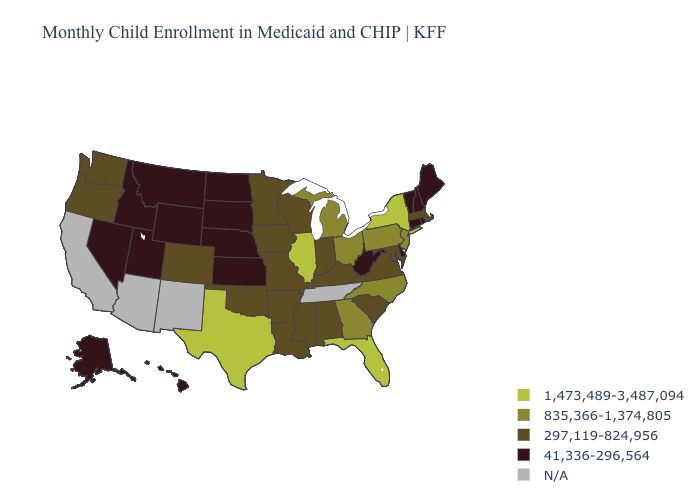Among the states that border New York , which have the highest value?
Give a very brief answer. New Jersey, Pennsylvania. What is the value of Missouri?
Give a very brief answer. 297,119-824,956. Name the states that have a value in the range N/A?
Quick response, please. Arizona, California, New Mexico, Tennessee. Does Connecticut have the highest value in the Northeast?
Keep it brief. No. Name the states that have a value in the range 297,119-824,956?
Quick response, please. Alabama, Arkansas, Colorado, Indiana, Iowa, Kentucky, Louisiana, Maryland, Massachusetts, Minnesota, Mississippi, Missouri, Oklahoma, Oregon, South Carolina, Virginia, Washington, Wisconsin. Does the map have missing data?
Quick response, please. Yes. What is the value of Kentucky?
Quick response, please. 297,119-824,956. Which states have the lowest value in the Northeast?
Quick response, please. Connecticut, Maine, New Hampshire, Rhode Island, Vermont. Among the states that border New Mexico , which have the lowest value?
Be succinct. Utah. Name the states that have a value in the range N/A?
Short answer required. Arizona, California, New Mexico, Tennessee. Does Utah have the highest value in the USA?
Concise answer only. No. What is the value of South Dakota?
Give a very brief answer. 41,336-296,564. Does the map have missing data?
Answer briefly. Yes. What is the value of Texas?
Keep it brief. 1,473,489-3,487,094. What is the highest value in the USA?
Write a very short answer. 1,473,489-3,487,094. 